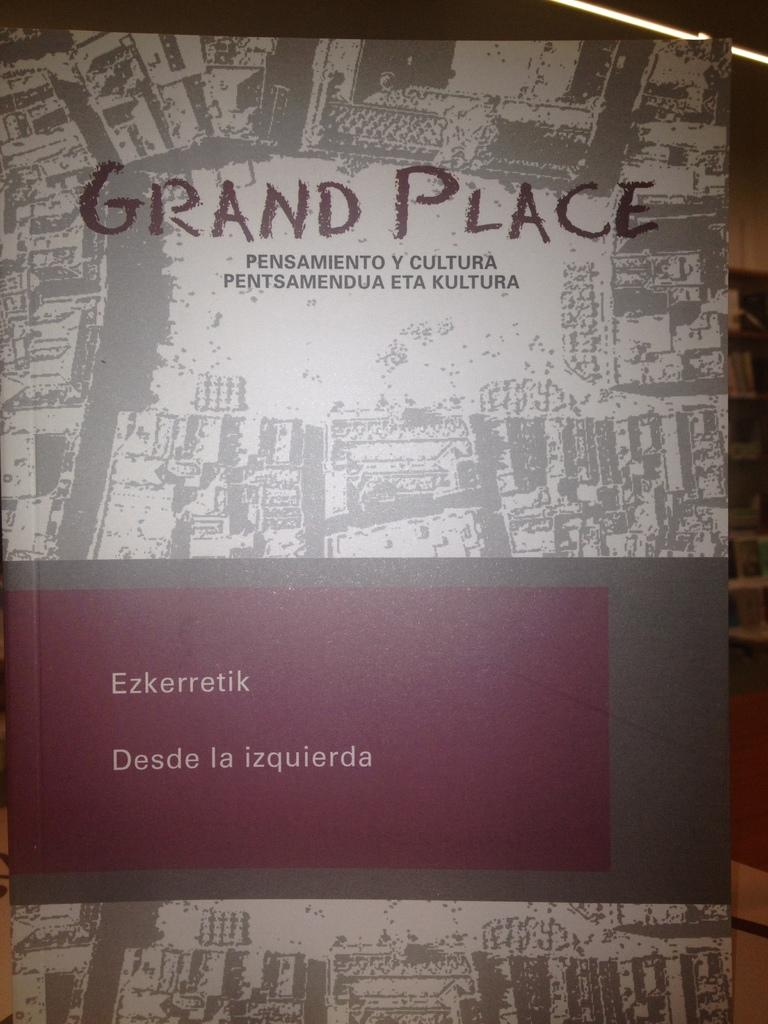<image>
Relay a brief, clear account of the picture shown. The book cover of Grand Place, which has a Spanish subtitle. 